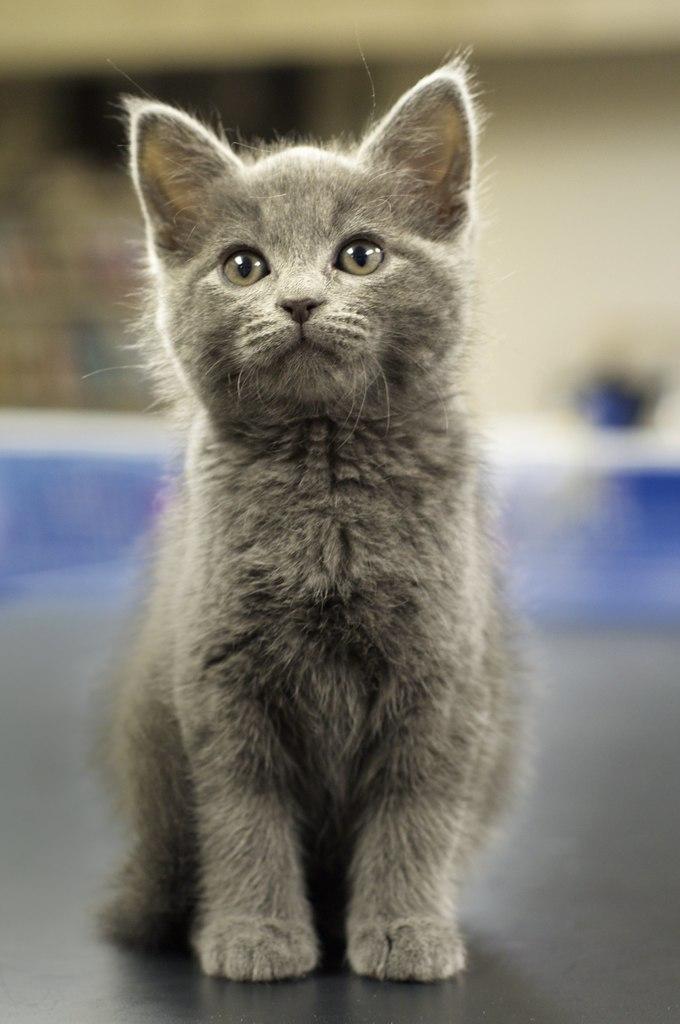In one or two sentences, can you explain what this image depicts? In the center of the image we can see a cat. On the backside we can see a wall. 